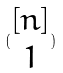<formula> <loc_0><loc_0><loc_500><loc_500>( \begin{matrix} [ n ] \\ 1 \end{matrix} )</formula> 